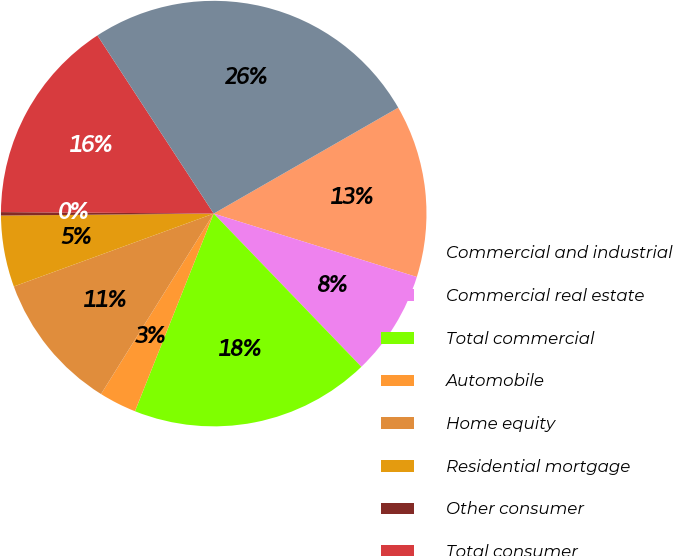<chart> <loc_0><loc_0><loc_500><loc_500><pie_chart><fcel>Commercial and industrial<fcel>Commercial real estate<fcel>Total commercial<fcel>Automobile<fcel>Home equity<fcel>Residential mortgage<fcel>Other consumer<fcel>Total consumer<fcel>Total ALLL<nl><fcel>13.11%<fcel>7.98%<fcel>18.24%<fcel>2.85%<fcel>10.55%<fcel>5.42%<fcel>0.26%<fcel>15.68%<fcel>25.91%<nl></chart> 